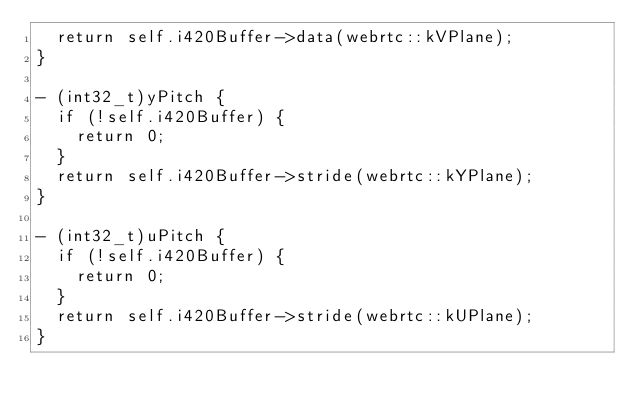<code> <loc_0><loc_0><loc_500><loc_500><_ObjectiveC_>  return self.i420Buffer->data(webrtc::kVPlane);
}

- (int32_t)yPitch {
  if (!self.i420Buffer) {
    return 0;
  }
  return self.i420Buffer->stride(webrtc::kYPlane);
}

- (int32_t)uPitch {
  if (!self.i420Buffer) {
    return 0;
  }
  return self.i420Buffer->stride(webrtc::kUPlane);
}
</code> 